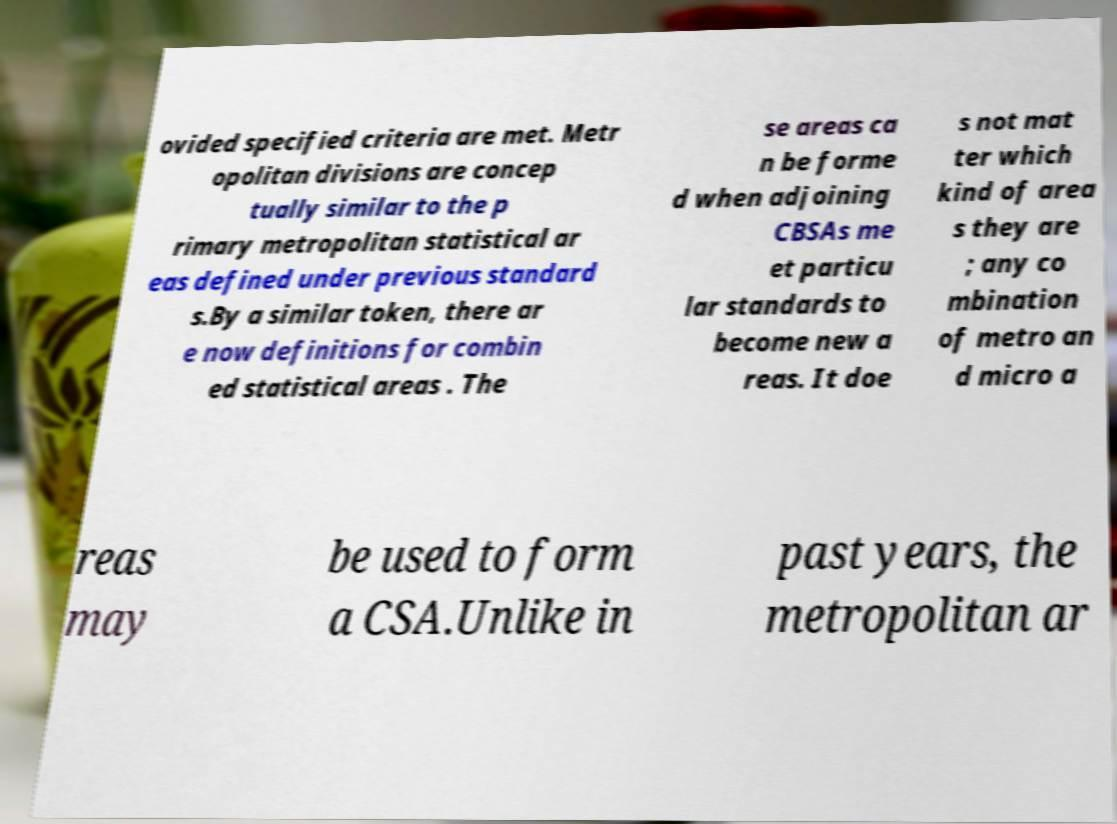For documentation purposes, I need the text within this image transcribed. Could you provide that? ovided specified criteria are met. Metr opolitan divisions are concep tually similar to the p rimary metropolitan statistical ar eas defined under previous standard s.By a similar token, there ar e now definitions for combin ed statistical areas . The se areas ca n be forme d when adjoining CBSAs me et particu lar standards to become new a reas. It doe s not mat ter which kind of area s they are ; any co mbination of metro an d micro a reas may be used to form a CSA.Unlike in past years, the metropolitan ar 